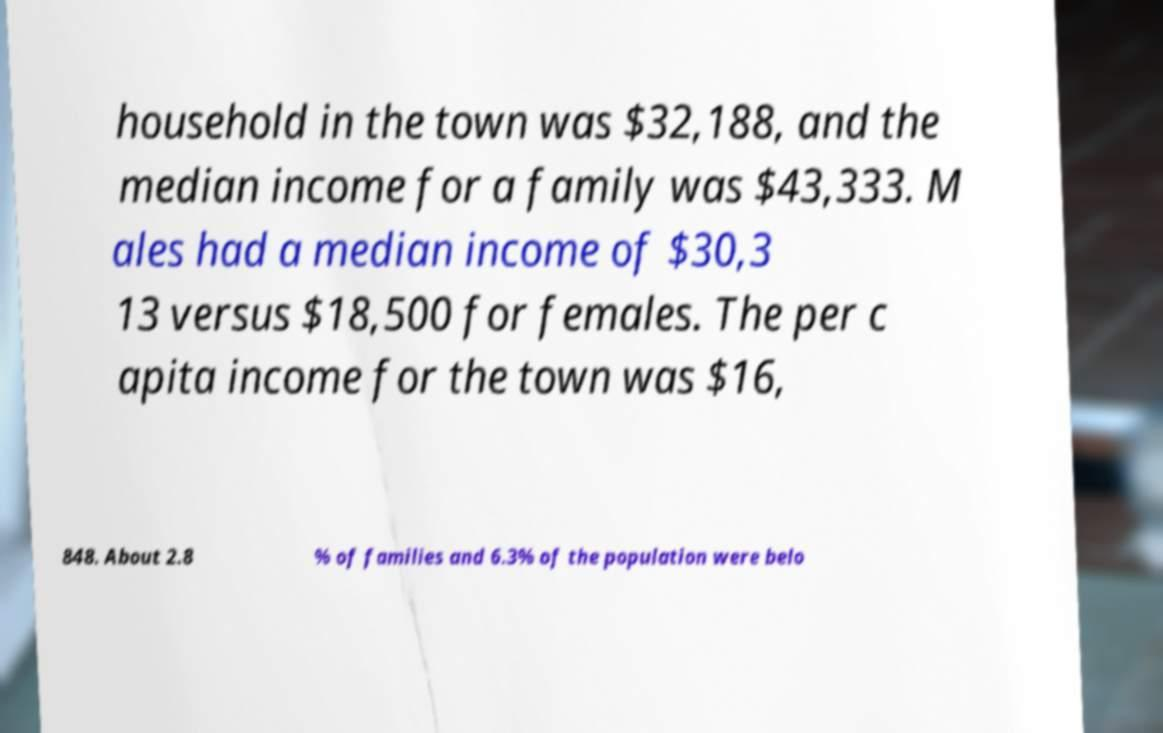Can you accurately transcribe the text from the provided image for me? household in the town was $32,188, and the median income for a family was $43,333. M ales had a median income of $30,3 13 versus $18,500 for females. The per c apita income for the town was $16, 848. About 2.8 % of families and 6.3% of the population were belo 